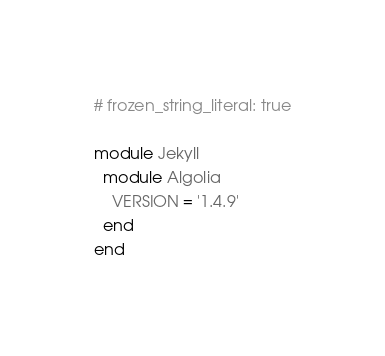Convert code to text. <code><loc_0><loc_0><loc_500><loc_500><_Ruby_># frozen_string_literal: true

module Jekyll
  module Algolia
    VERSION = '1.4.9'
  end
end
</code> 